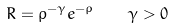<formula> <loc_0><loc_0><loc_500><loc_500>R = \rho ^ { - \gamma } e ^ { - \rho } \quad \gamma > 0</formula> 